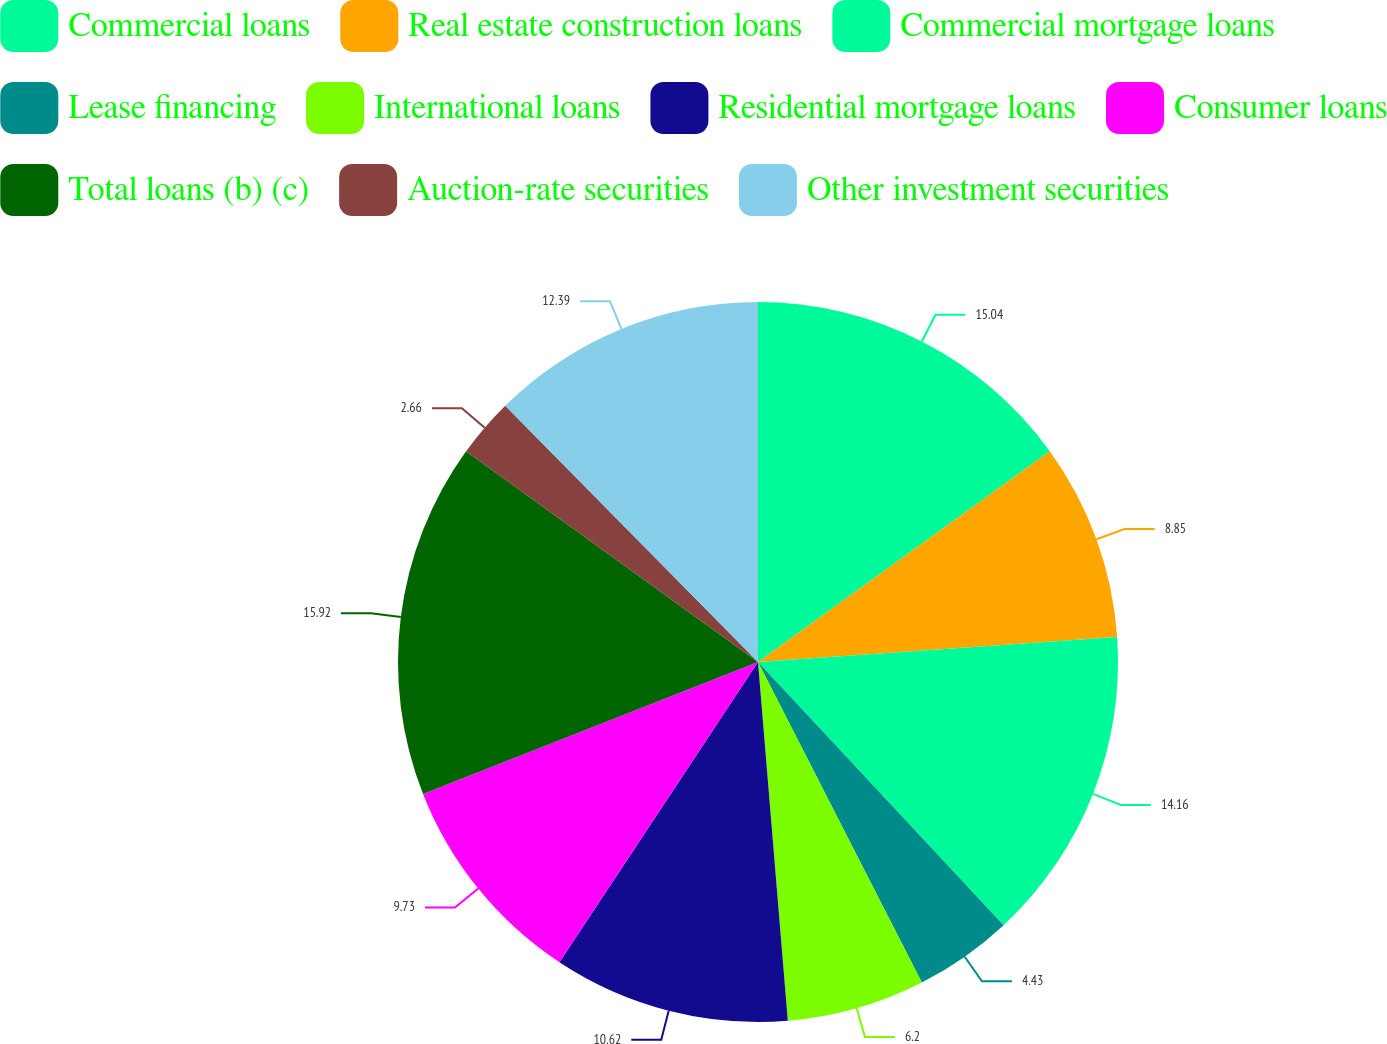Convert chart to OTSL. <chart><loc_0><loc_0><loc_500><loc_500><pie_chart><fcel>Commercial loans<fcel>Real estate construction loans<fcel>Commercial mortgage loans<fcel>Lease financing<fcel>International loans<fcel>Residential mortgage loans<fcel>Consumer loans<fcel>Total loans (b) (c)<fcel>Auction-rate securities<fcel>Other investment securities<nl><fcel>15.04%<fcel>8.85%<fcel>14.16%<fcel>4.43%<fcel>6.2%<fcel>10.62%<fcel>9.73%<fcel>15.92%<fcel>2.66%<fcel>12.39%<nl></chart> 